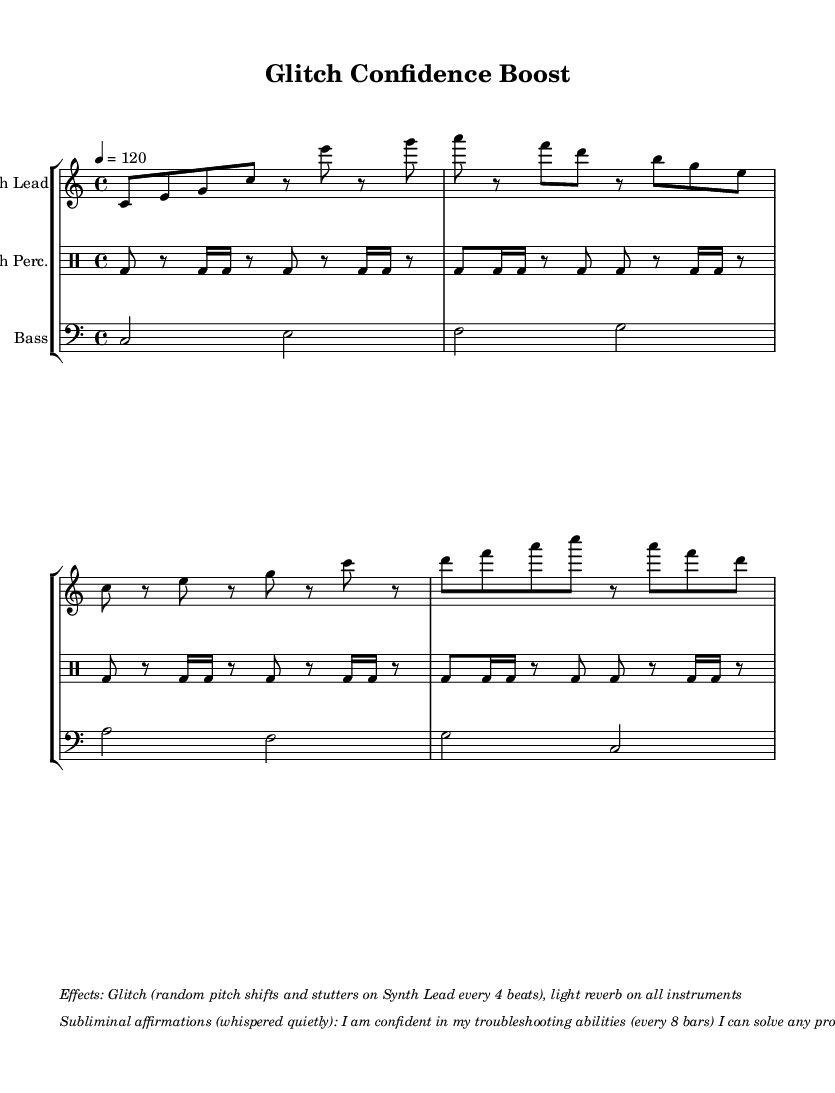What is the key signature of this music? The key signature is indicated by the key signature symbol at the beginning of the staff, and it shows that there are no sharps or flats, which denotes C major.
Answer: C major What is the time signature of this music? The time signature is shown at the beginning of the score, represented as 4/4, which means there are four beats in each measure and the quarter note receives one beat.
Answer: 4/4 What is the tempo marking of the piece? The tempo marking is indicated on the score, stating that the piece is to be played at 120 beats per minute, which is expressed as "4 = 120."
Answer: 120 What type of percussion is used in this piece? The piece uses a specific notation system for percussion instruments, as indicated by the "clef percussion" marking at the start of the glitch percussion staff, identifying the drumming part.
Answer: Glitch Percussion How often do the subliminal affirmations occur in the music? The score indicates that the first affirmation occurs every 8 bars and the second affirmation occurs every 16 bars; this is detailed in the markup section of the score itself.
Answer: Every 8 and 16 bars What effect is applied to the Synth Lead? The effects are described in the markup section of the score, which notes "glitch" as a main effect, involving random pitch shifts and stutters that occur every 4 beats on the synth lead.
Answer: Glitch 